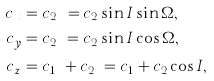Convert formula to latex. <formula><loc_0><loc_0><loc_500><loc_500>c _ { x } & = c _ { 2 _ { x } } = c _ { 2 } \sin { I } \sin { \Omega } , \\ c _ { y } & = c _ { 2 _ { y } } = c _ { 2 } \sin { I } \cos { \Omega } , \\ c _ { z } & = c _ { 1 _ { z } } + c _ { 2 _ { z } } = c _ { 1 } + c _ { 2 } \cos { I } ,</formula> 